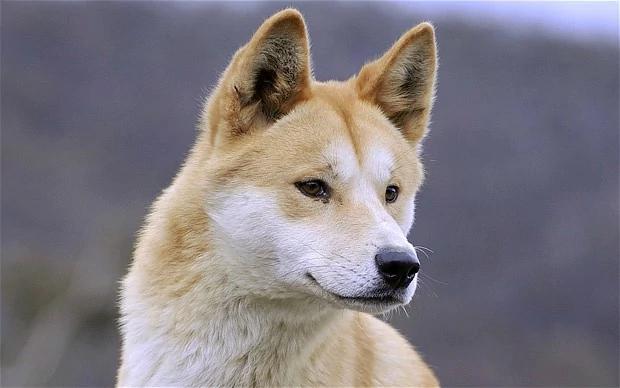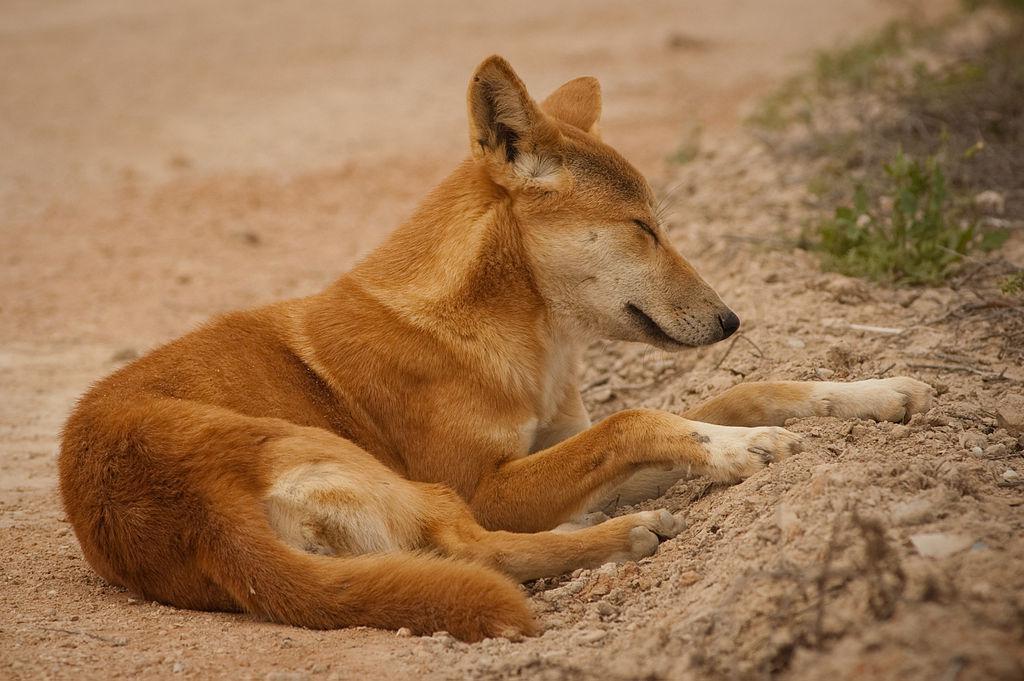The first image is the image on the left, the second image is the image on the right. For the images displayed, is the sentence "One of the images shows a dog laying near a tree." factually correct? Answer yes or no. No. The first image is the image on the left, the second image is the image on the right. Examine the images to the left and right. Is the description "Each image shows one reclining orange dingo with its eyes closed and its head down instead of raised, and no dingos are tiny pups." accurate? Answer yes or no. No. 